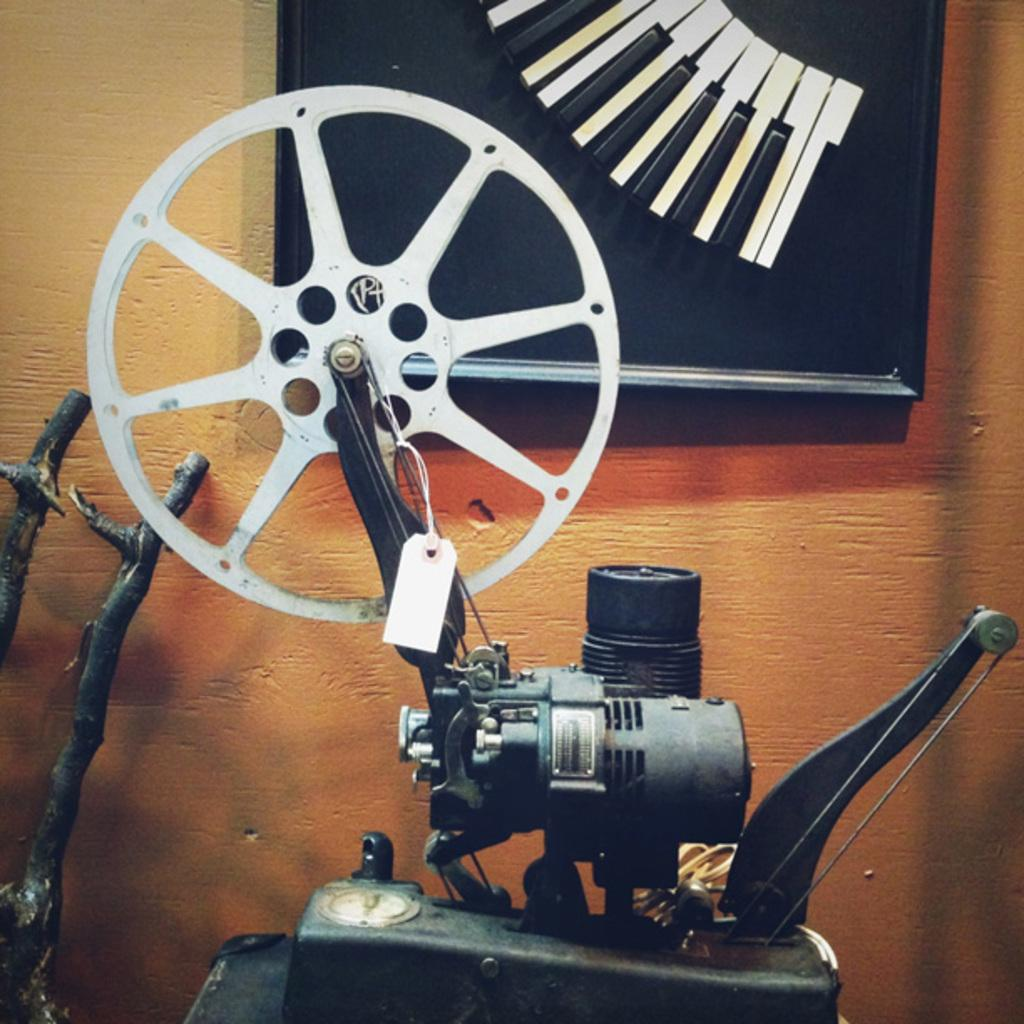What type of machine is visible in the image? There is a machine with an engine and wheel in the image. What is located behind the machine? There is a wall with a frame behind the machine. What can be seen on the left side of the image? There are sticks on the left side of the image. What company is responsible for the mind-reading technology in the image? There is no mention of mind-reading technology or any company in the image. 